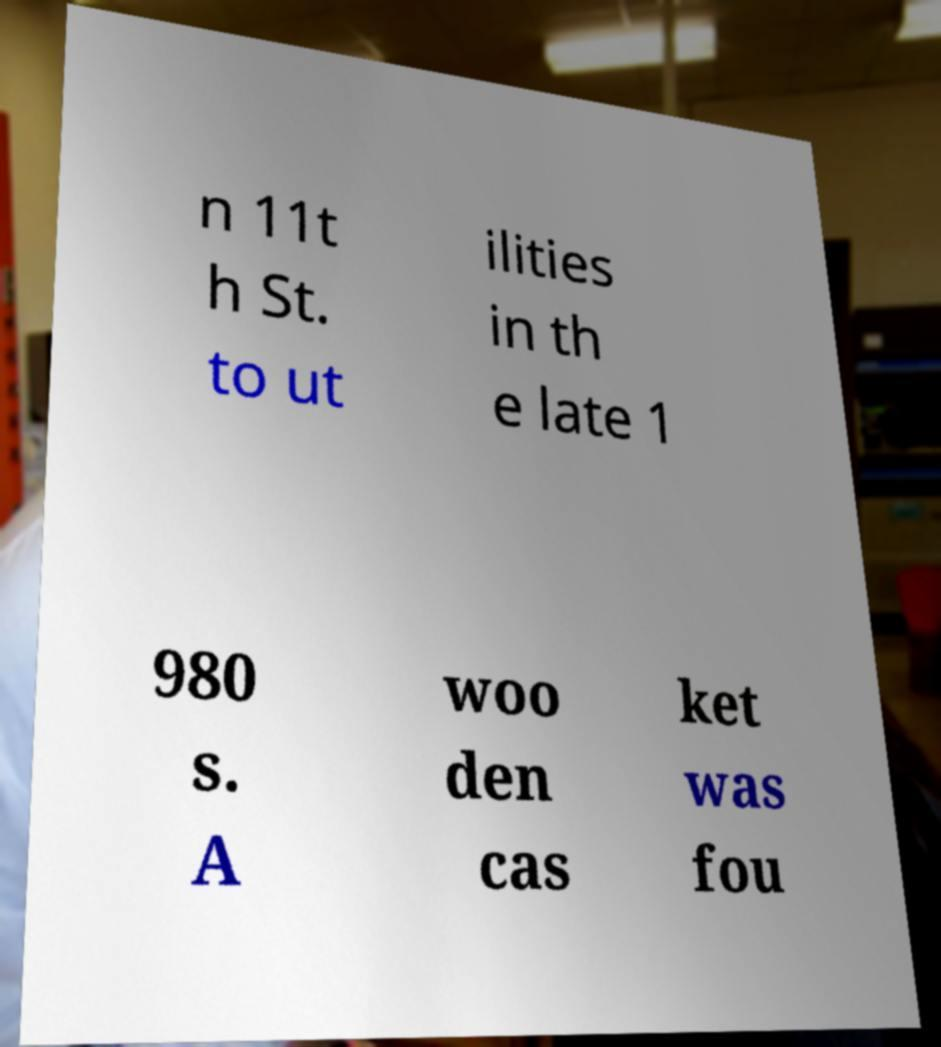For documentation purposes, I need the text within this image transcribed. Could you provide that? n 11t h St. to ut ilities in th e late 1 980 s. A woo den cas ket was fou 